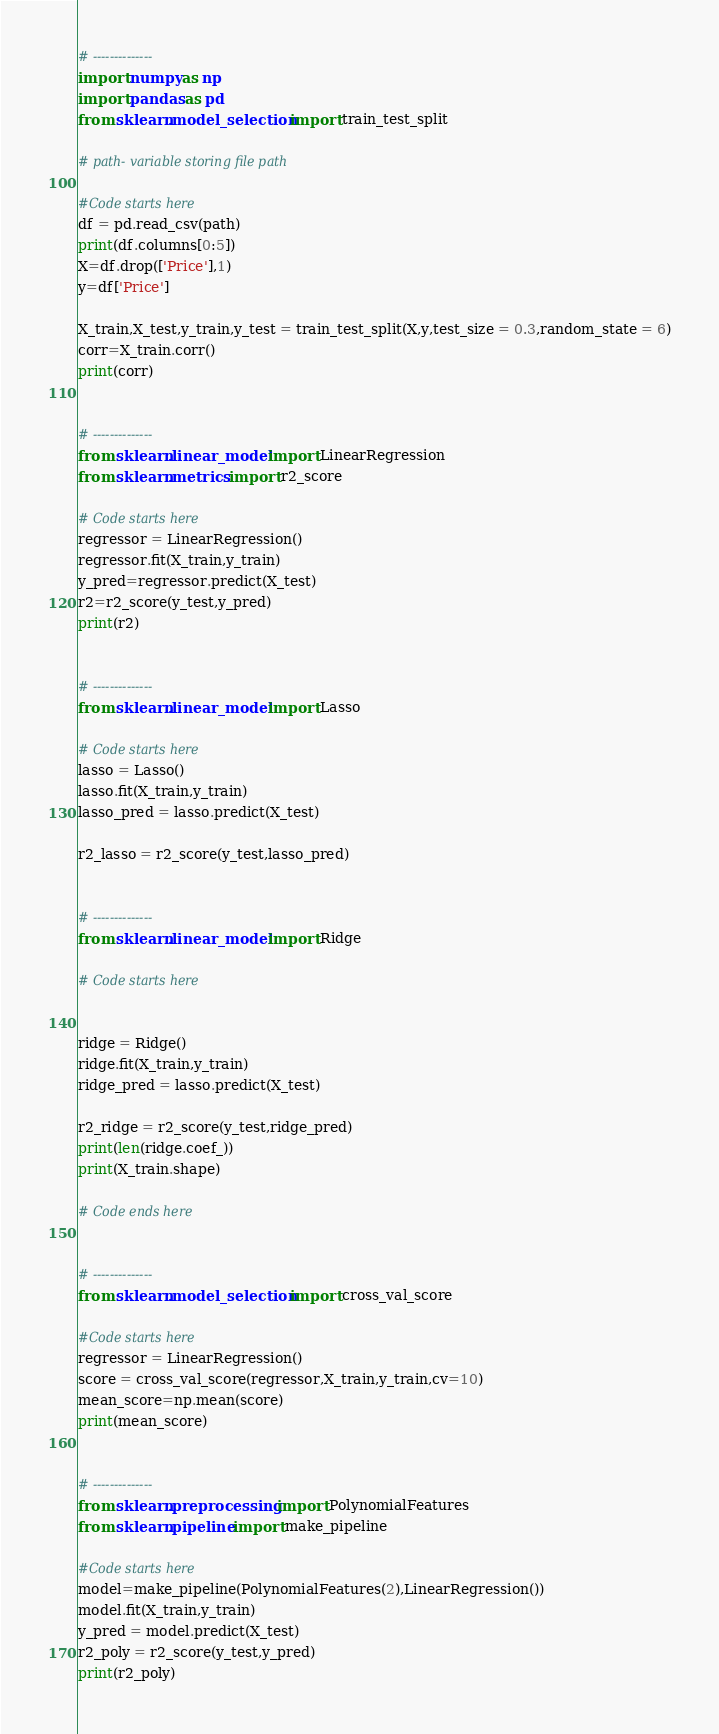Convert code to text. <code><loc_0><loc_0><loc_500><loc_500><_Python_># --------------
import numpy as np
import pandas as pd
from sklearn.model_selection import train_test_split

# path- variable storing file path

#Code starts here
df = pd.read_csv(path)
print(df.columns[0:5])
X=df.drop(['Price'],1)
y=df['Price']

X_train,X_test,y_train,y_test = train_test_split(X,y,test_size = 0.3,random_state = 6)
corr=X_train.corr()
print(corr)


# --------------
from sklearn.linear_model import LinearRegression
from sklearn.metrics import r2_score

# Code starts here
regressor = LinearRegression()
regressor.fit(X_train,y_train)
y_pred=regressor.predict(X_test)
r2=r2_score(y_test,y_pred)
print(r2)


# --------------
from sklearn.linear_model import Lasso

# Code starts here
lasso = Lasso()
lasso.fit(X_train,y_train)
lasso_pred = lasso.predict(X_test)

r2_lasso = r2_score(y_test,lasso_pred)


# --------------
from sklearn.linear_model import Ridge

# Code starts here


ridge = Ridge()
ridge.fit(X_train,y_train)
ridge_pred = lasso.predict(X_test)

r2_ridge = r2_score(y_test,ridge_pred)
print(len(ridge.coef_))
print(X_train.shape)

# Code ends here


# --------------
from sklearn.model_selection import cross_val_score

#Code starts here
regressor = LinearRegression()
score = cross_val_score(regressor,X_train,y_train,cv=10)
mean_score=np.mean(score)
print(mean_score)


# --------------
from sklearn.preprocessing import PolynomialFeatures
from sklearn.pipeline import make_pipeline

#Code starts here
model=make_pipeline(PolynomialFeatures(2),LinearRegression())
model.fit(X_train,y_train)
y_pred = model.predict(X_test)
r2_poly = r2_score(y_test,y_pred)
print(r2_poly)


</code> 